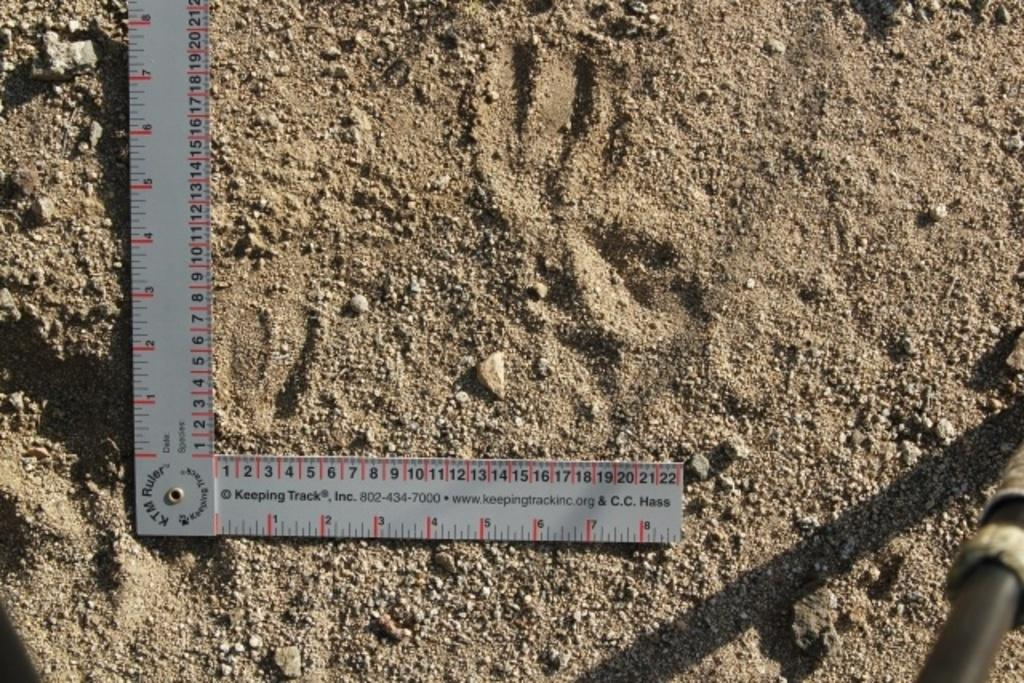<image>
Present a compact description of the photo's key features. A KTM ruler with a 90 degree angle in it. 